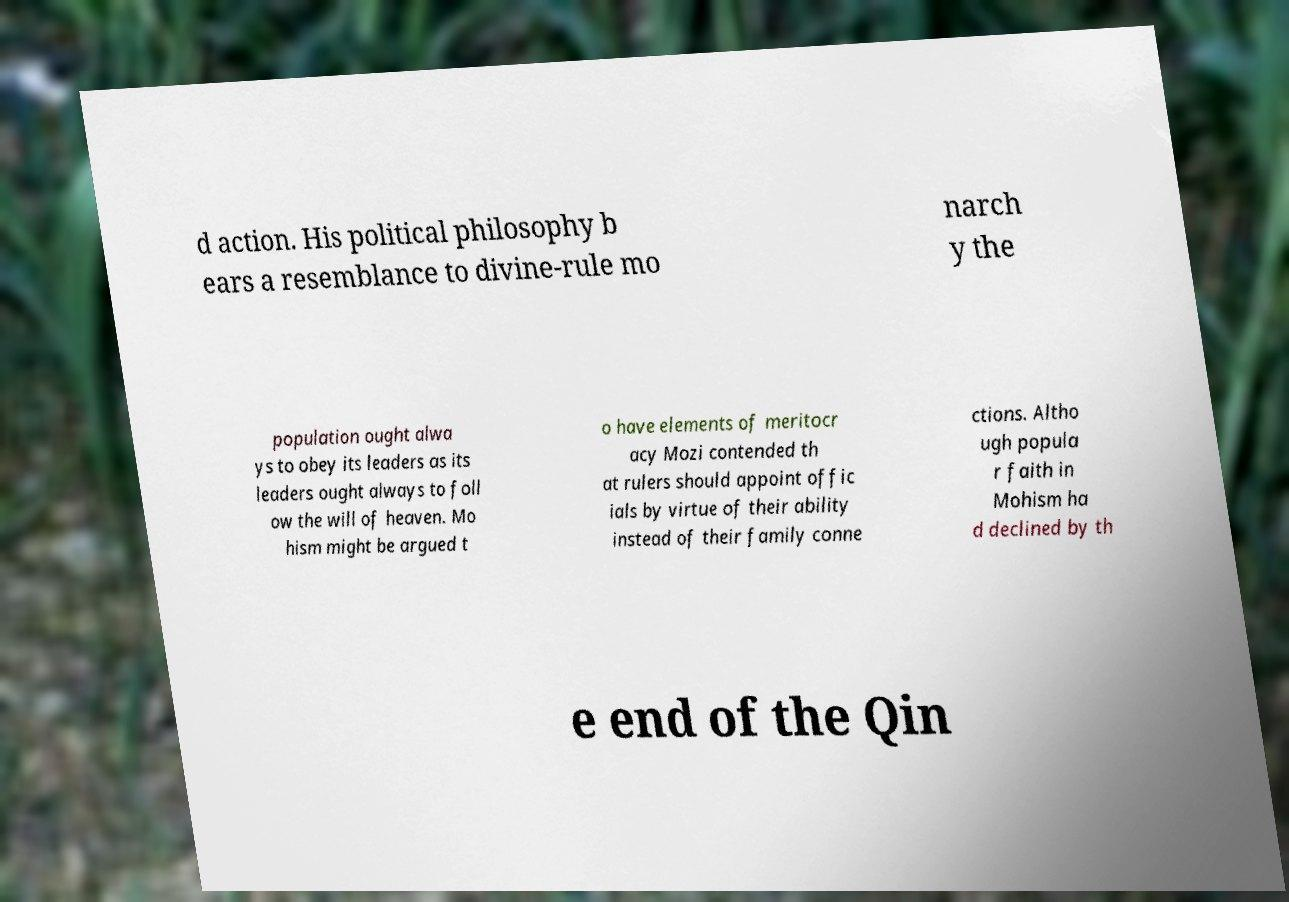Could you assist in decoding the text presented in this image and type it out clearly? d action. His political philosophy b ears a resemblance to divine-rule mo narch y the population ought alwa ys to obey its leaders as its leaders ought always to foll ow the will of heaven. Mo hism might be argued t o have elements of meritocr acy Mozi contended th at rulers should appoint offic ials by virtue of their ability instead of their family conne ctions. Altho ugh popula r faith in Mohism ha d declined by th e end of the Qin 